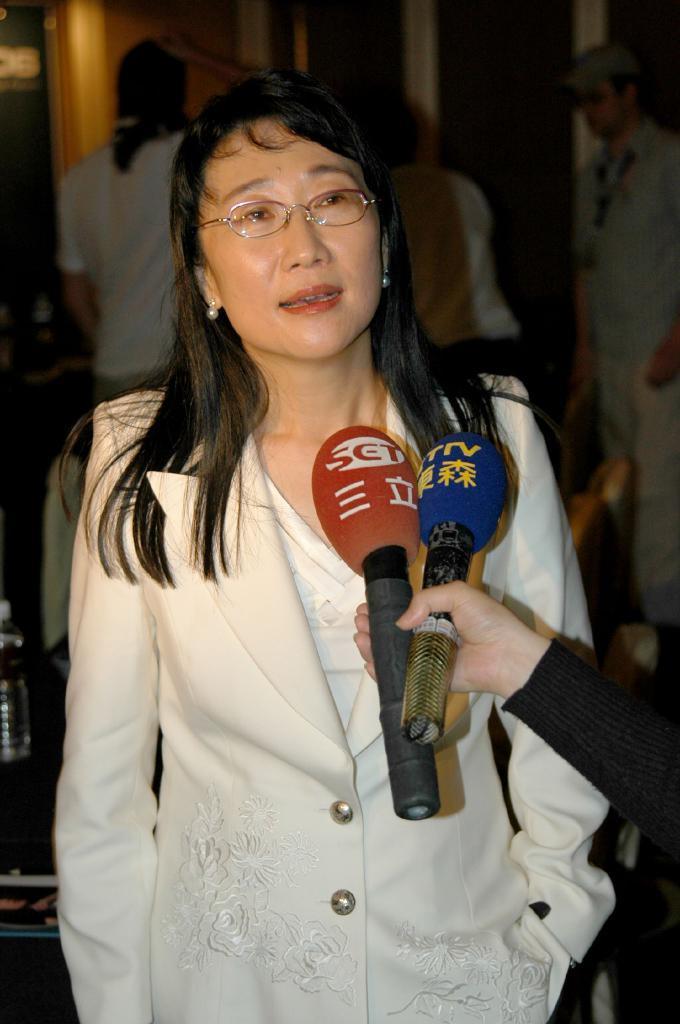In one or two sentences, can you explain what this image depicts? In this picture we can see a woman in the white dress. On the left side of the image, there is a hand of a person and the person is holding the microphones. Behind the women, there are people, a bottle and some other objects. 